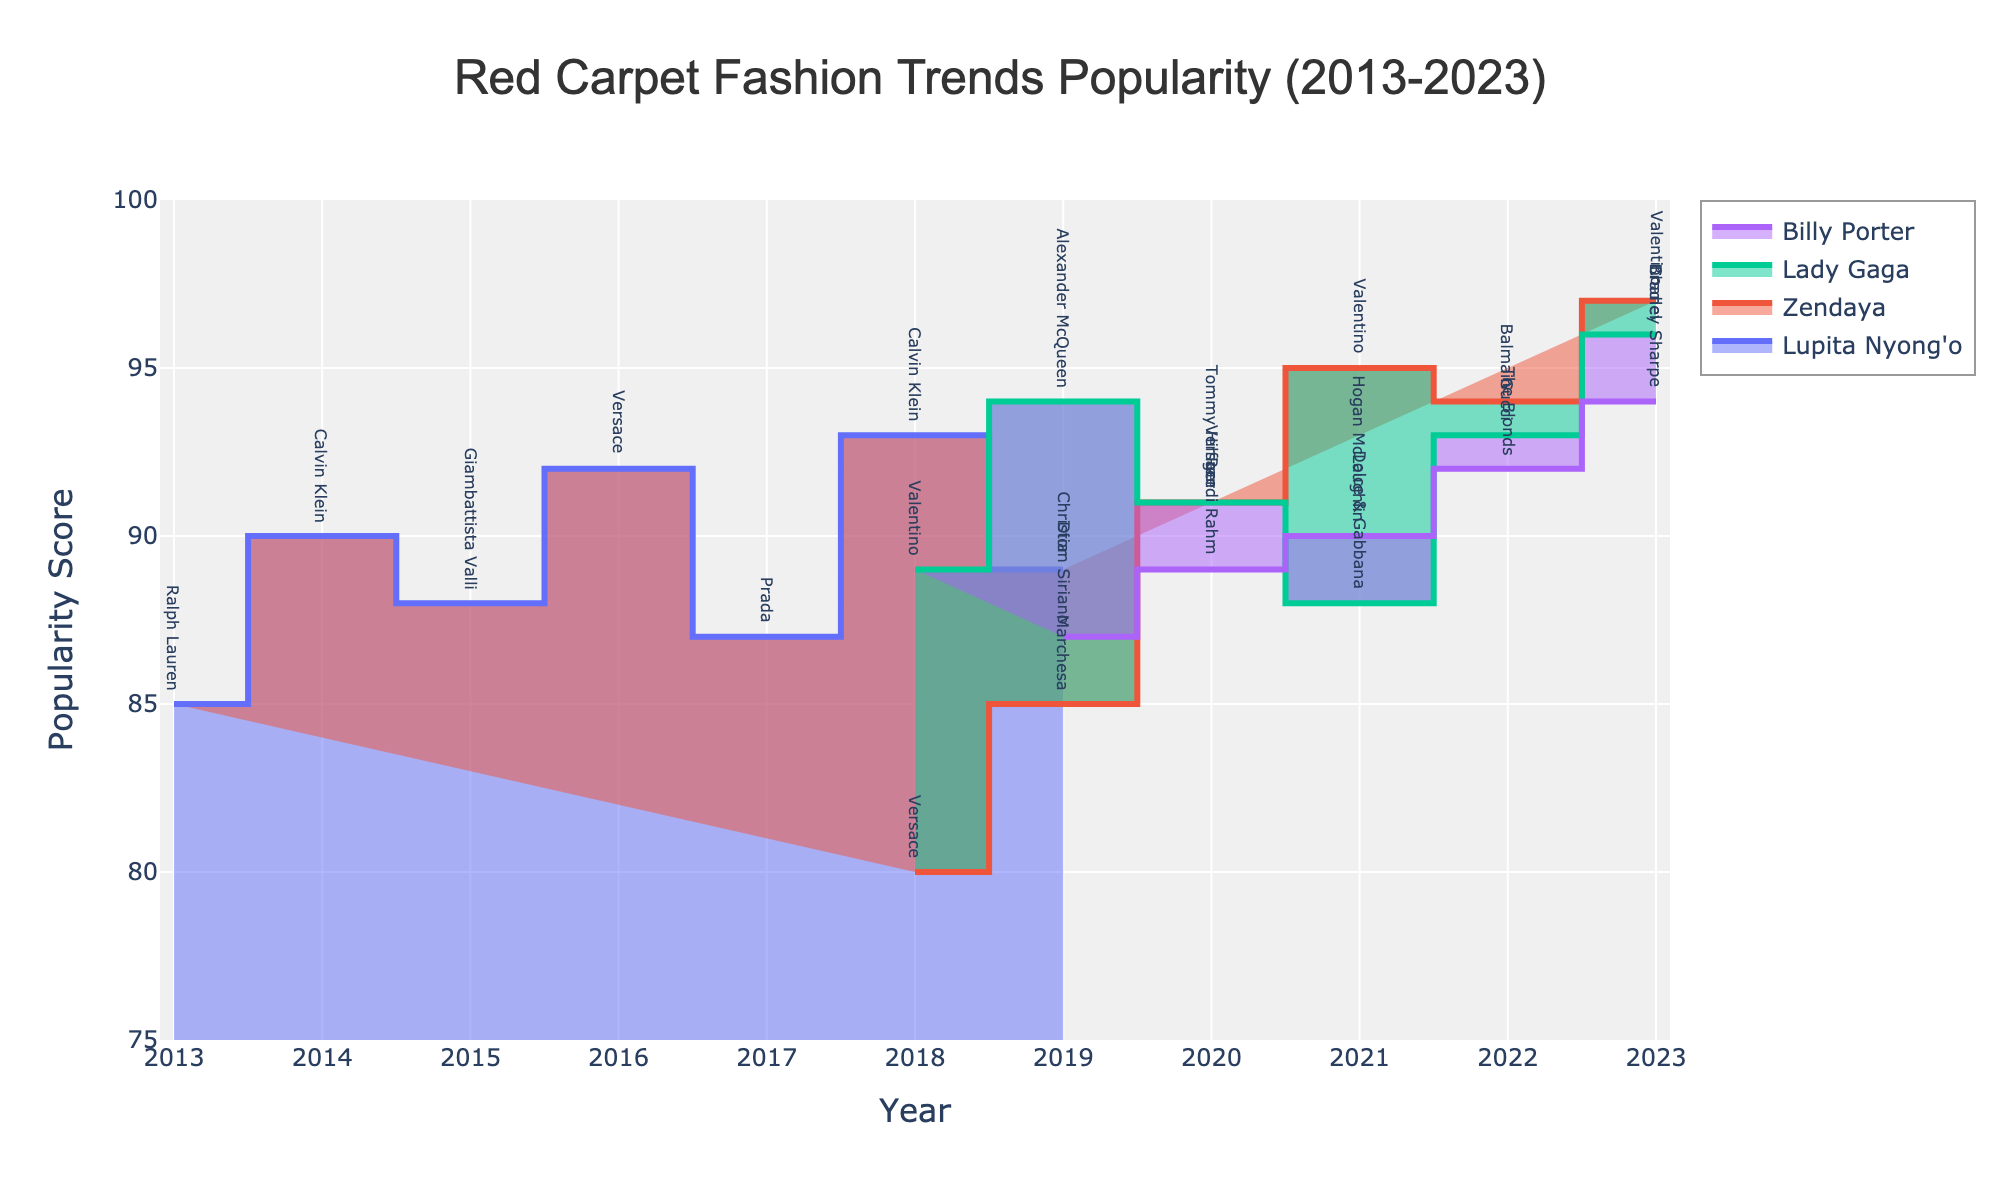Who endorsed Ralph Lauren on the red carpet in 2013? The chart shows the popularity score for each celebrity-designer combination over different years. The point at 2013 with Ralph Lauren shows a score associated with Lupita Nyong'o.
Answer: Lupita Nyong'o What's the title of the figure? The title is located at the top center of the figure and reads "Red Carpet Fashion Trends Popularity (2013-2023)."
Answer: Red Carpet Fashion Trends Popularity (2013-2023) Which celebrity had the highest popularity score in 2023? By examining the popularity scores for each celebrity in 2023, the highest value is marked for Zendaya with Valentino and Lady Gaga with Chanel, both having a score of 97.
Answer: Zendaya What is the difference in popularity score between Zendaya and Lady Gaga in 2020? From the chart, Zendaya has a score of 91 in 2020 while Lady Gaga has a score of 91. The difference is 0.
Answer: 0 Which designer collaboration for Lupita Nyong'o had the highest score, and in what year? By checking the peak points for Lupita Nyong’o, her highest popularity score is 93 in 2018 which is attributed to her collaboration with Calvin Klein.
Answer: Calvin Klein, 2018 How do the 2021 and 2022 popularity scores for Billy Porter compare? Billy Porter's popularity score in 2021 is 90 while in 2022 it is 92. Comparing these two scores: 2022 is higher by 2 points.
Answer: 2 points Who had a consistent increase in their popularity score from 2021 to 2023? By observing the trend lines for each celebrity, Billy Porter exhibits a consistent increase from 2021 (90) to 2023 (94).
Answer: Billy Porter Identify the fashion designer with the highest popularity score in the data. The designer Valentino has a score of 97 associated with Zendaya in 2023. This is the highest score noted in the chart.
Answer: Valentino How many celebrities' popularity scores are visualized in the chart? Counting the distinct popularity trend lines displayed for different celebrities, four are visualized: Lupita Nyong'o, Zendaya, Lady Gaga, and Billy Porter.
Answer: 4 Which designer did Lady Gaga partner with in 2022, and what was her popularity score? Reviewing the 2022 data for Lady Gaga, she collaborated with Gucci and had a popularity score of 93.
Answer: Gucci, 93 